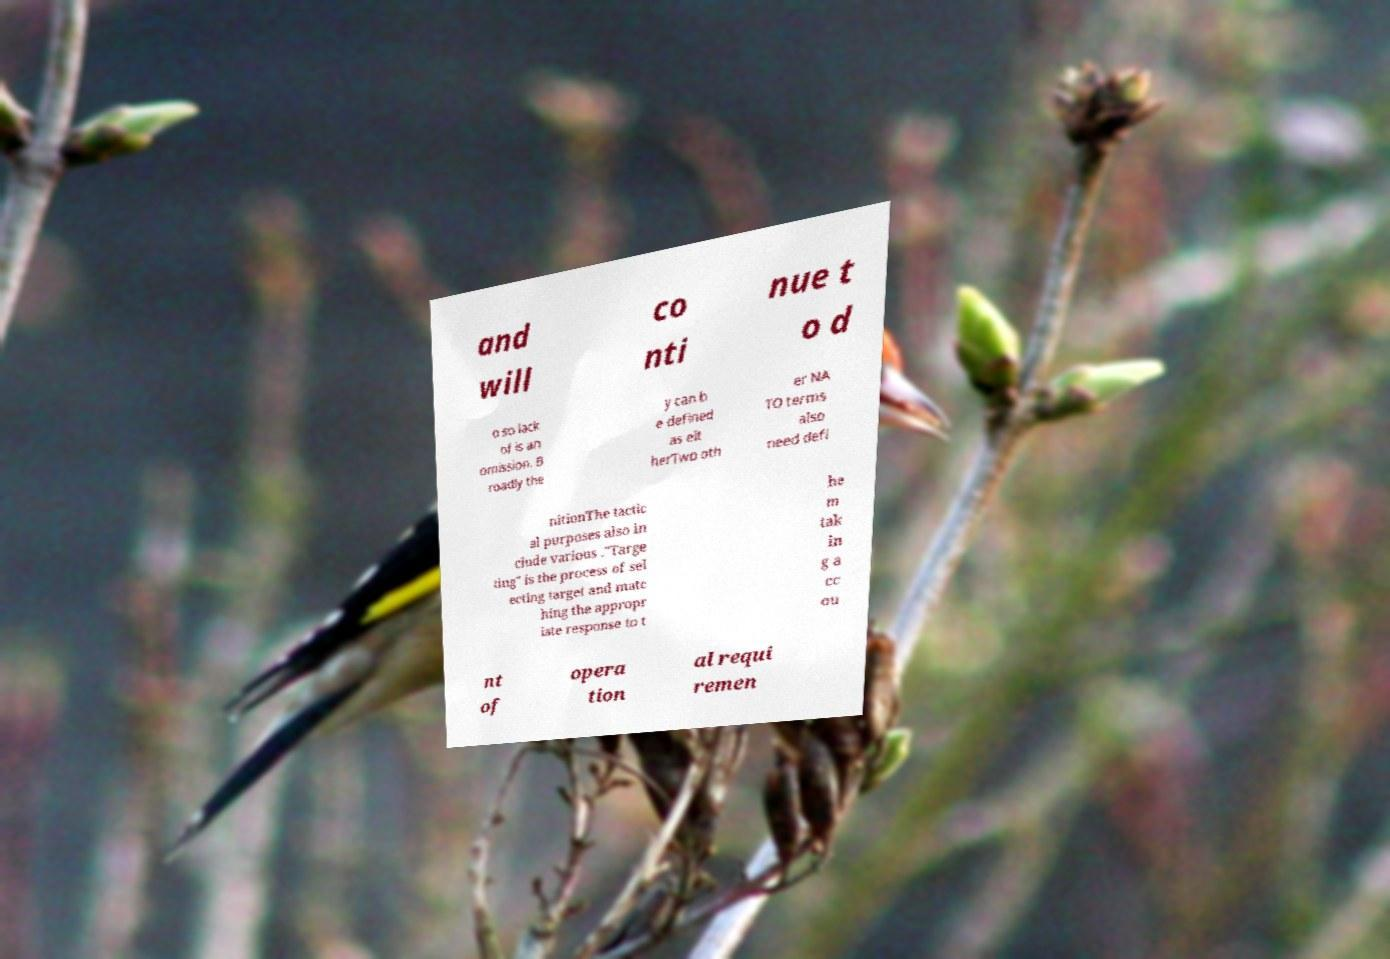Could you extract and type out the text from this image? and will co nti nue t o d o so lack of is an omission. B roadly the y can b e defined as eit herTwo oth er NA TO terms also need defi nitionThe tactic al purposes also in clude various ."Targe ting" is the process of sel ecting target and matc hing the appropr iate response to t he m tak in g a cc ou nt of opera tion al requi remen 